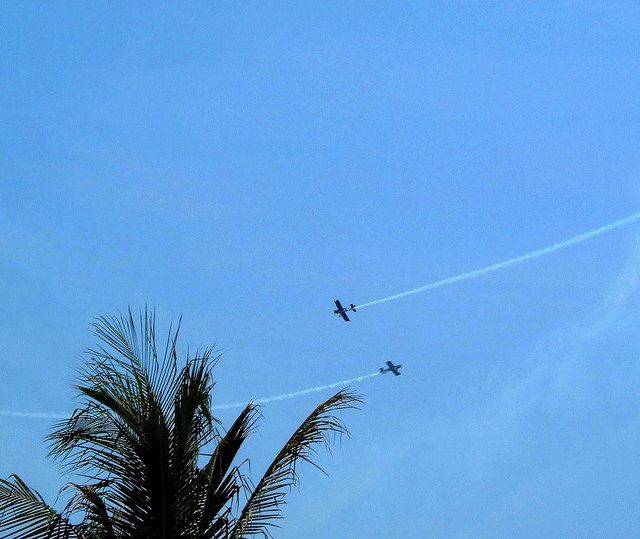<image>What kind of clouds are in the sky? I don't know what kind of clouds are in the sky. There might be none or there could be some wispy, stratus, or condensation clouds. What kind of clouds are in the sky? There are no clouds in the sky. 